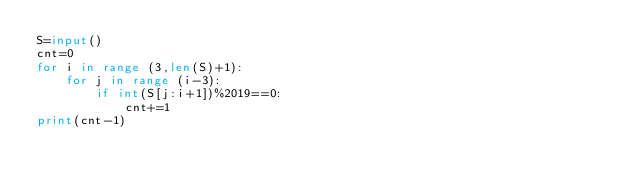Convert code to text. <code><loc_0><loc_0><loc_500><loc_500><_Python_>S=input()
cnt=0
for i in range (3,len(S)+1):
    for j in range (i-3):
        if int(S[j:i+1])%2019==0:
            cnt+=1
print(cnt-1)</code> 